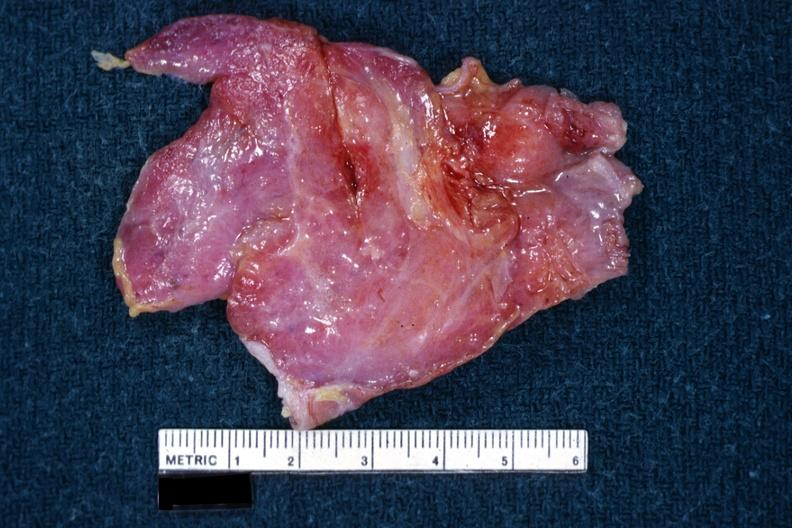s blood present?
Answer the question using a single word or phrase. No 